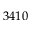Convert formula to latex. <formula><loc_0><loc_0><loc_500><loc_500>3 4 1 0</formula> 